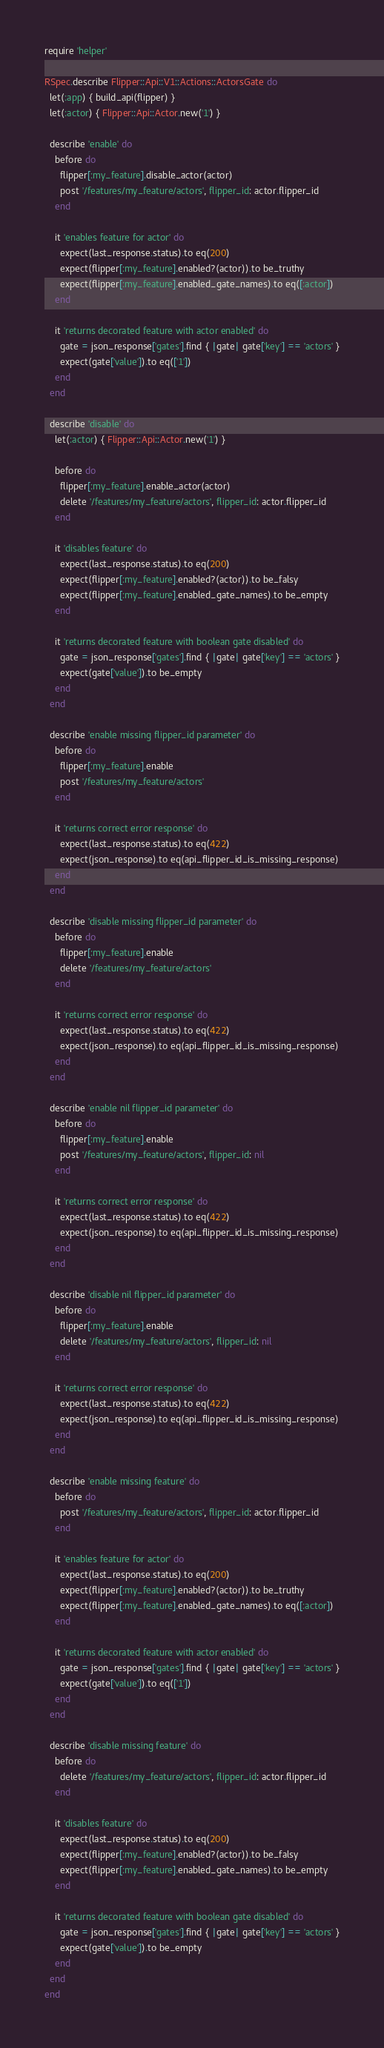Convert code to text. <code><loc_0><loc_0><loc_500><loc_500><_Ruby_>require 'helper'

RSpec.describe Flipper::Api::V1::Actions::ActorsGate do
  let(:app) { build_api(flipper) }
  let(:actor) { Flipper::Api::Actor.new('1') }

  describe 'enable' do
    before do
      flipper[:my_feature].disable_actor(actor)
      post '/features/my_feature/actors', flipper_id: actor.flipper_id
    end

    it 'enables feature for actor' do
      expect(last_response.status).to eq(200)
      expect(flipper[:my_feature].enabled?(actor)).to be_truthy
      expect(flipper[:my_feature].enabled_gate_names).to eq([:actor])
    end

    it 'returns decorated feature with actor enabled' do
      gate = json_response['gates'].find { |gate| gate['key'] == 'actors' }
      expect(gate['value']).to eq(['1'])
    end
  end

  describe 'disable' do
    let(:actor) { Flipper::Api::Actor.new('1') }

    before do
      flipper[:my_feature].enable_actor(actor)
      delete '/features/my_feature/actors', flipper_id: actor.flipper_id
    end

    it 'disables feature' do
      expect(last_response.status).to eq(200)
      expect(flipper[:my_feature].enabled?(actor)).to be_falsy
      expect(flipper[:my_feature].enabled_gate_names).to be_empty
    end

    it 'returns decorated feature with boolean gate disabled' do
      gate = json_response['gates'].find { |gate| gate['key'] == 'actors' }
      expect(gate['value']).to be_empty
    end
  end

  describe 'enable missing flipper_id parameter' do
    before do
      flipper[:my_feature].enable
      post '/features/my_feature/actors'
    end

    it 'returns correct error response' do
      expect(last_response.status).to eq(422)
      expect(json_response).to eq(api_flipper_id_is_missing_response)
    end
  end

  describe 'disable missing flipper_id parameter' do
    before do
      flipper[:my_feature].enable
      delete '/features/my_feature/actors'
    end

    it 'returns correct error response' do
      expect(last_response.status).to eq(422)
      expect(json_response).to eq(api_flipper_id_is_missing_response)
    end
  end

  describe 'enable nil flipper_id parameter' do
    before do
      flipper[:my_feature].enable
      post '/features/my_feature/actors', flipper_id: nil
    end

    it 'returns correct error response' do
      expect(last_response.status).to eq(422)
      expect(json_response).to eq(api_flipper_id_is_missing_response)
    end
  end

  describe 'disable nil flipper_id parameter' do
    before do
      flipper[:my_feature].enable
      delete '/features/my_feature/actors', flipper_id: nil
    end

    it 'returns correct error response' do
      expect(last_response.status).to eq(422)
      expect(json_response).to eq(api_flipper_id_is_missing_response)
    end
  end

  describe 'enable missing feature' do
    before do
      post '/features/my_feature/actors', flipper_id: actor.flipper_id
    end

    it 'enables feature for actor' do
      expect(last_response.status).to eq(200)
      expect(flipper[:my_feature].enabled?(actor)).to be_truthy
      expect(flipper[:my_feature].enabled_gate_names).to eq([:actor])
    end

    it 'returns decorated feature with actor enabled' do
      gate = json_response['gates'].find { |gate| gate['key'] == 'actors' }
      expect(gate['value']).to eq(['1'])
    end
  end

  describe 'disable missing feature' do
    before do
      delete '/features/my_feature/actors', flipper_id: actor.flipper_id
    end

    it 'disables feature' do
      expect(last_response.status).to eq(200)
      expect(flipper[:my_feature].enabled?(actor)).to be_falsy
      expect(flipper[:my_feature].enabled_gate_names).to be_empty
    end

    it 'returns decorated feature with boolean gate disabled' do
      gate = json_response['gates'].find { |gate| gate['key'] == 'actors' }
      expect(gate['value']).to be_empty
    end
  end
end
</code> 